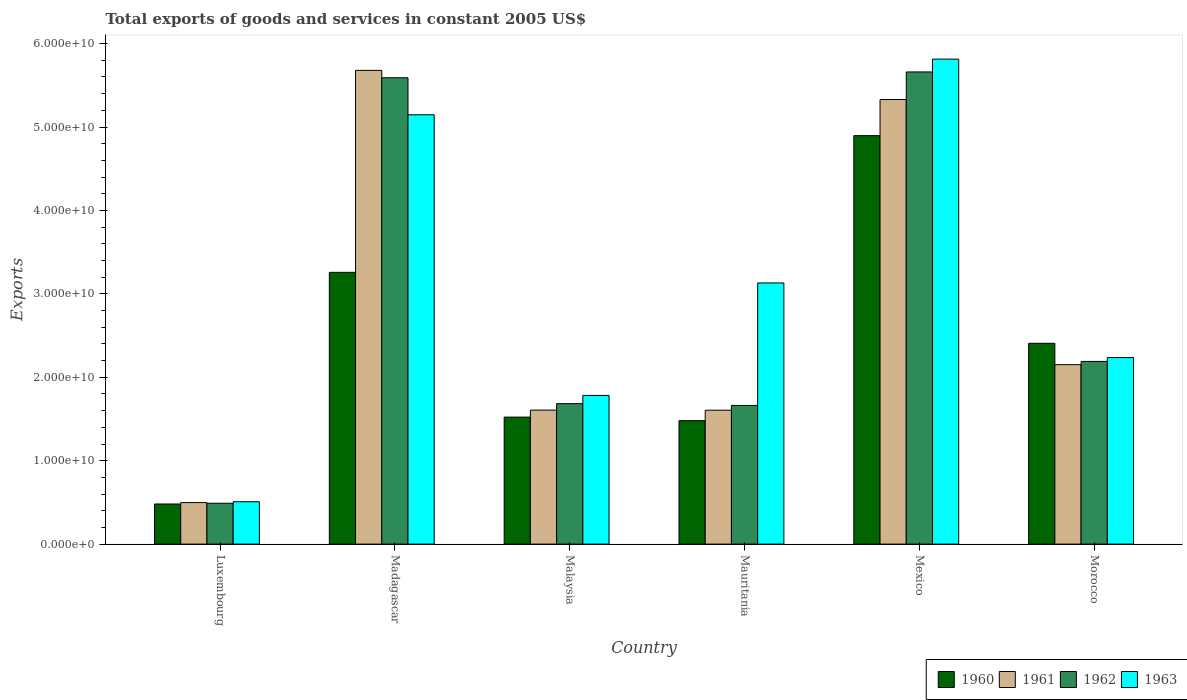How many groups of bars are there?
Give a very brief answer. 6. Are the number of bars per tick equal to the number of legend labels?
Ensure brevity in your answer.  Yes. How many bars are there on the 1st tick from the left?
Provide a short and direct response. 4. What is the label of the 2nd group of bars from the left?
Your answer should be very brief. Madagascar. What is the total exports of goods and services in 1963 in Morocco?
Your answer should be compact. 2.24e+1. Across all countries, what is the maximum total exports of goods and services in 1962?
Make the answer very short. 5.66e+1. Across all countries, what is the minimum total exports of goods and services in 1963?
Provide a succinct answer. 5.08e+09. In which country was the total exports of goods and services in 1962 maximum?
Ensure brevity in your answer.  Mexico. In which country was the total exports of goods and services in 1960 minimum?
Your response must be concise. Luxembourg. What is the total total exports of goods and services in 1962 in the graph?
Provide a succinct answer. 1.73e+11. What is the difference between the total exports of goods and services in 1963 in Luxembourg and that in Mauritania?
Offer a very short reply. -2.62e+1. What is the difference between the total exports of goods and services in 1960 in Mauritania and the total exports of goods and services in 1961 in Morocco?
Give a very brief answer. -6.71e+09. What is the average total exports of goods and services in 1961 per country?
Provide a succinct answer. 2.81e+1. What is the difference between the total exports of goods and services of/in 1961 and total exports of goods and services of/in 1963 in Malaysia?
Keep it short and to the point. -1.76e+09. In how many countries, is the total exports of goods and services in 1961 greater than 34000000000 US$?
Provide a succinct answer. 2. What is the ratio of the total exports of goods and services in 1963 in Malaysia to that in Mauritania?
Ensure brevity in your answer.  0.57. Is the total exports of goods and services in 1960 in Malaysia less than that in Mexico?
Provide a short and direct response. Yes. Is the difference between the total exports of goods and services in 1961 in Madagascar and Mexico greater than the difference between the total exports of goods and services in 1963 in Madagascar and Mexico?
Offer a terse response. Yes. What is the difference between the highest and the second highest total exports of goods and services in 1961?
Your response must be concise. 3.50e+09. What is the difference between the highest and the lowest total exports of goods and services in 1962?
Provide a succinct answer. 5.17e+1. In how many countries, is the total exports of goods and services in 1960 greater than the average total exports of goods and services in 1960 taken over all countries?
Your answer should be compact. 3. Is the sum of the total exports of goods and services in 1961 in Luxembourg and Malaysia greater than the maximum total exports of goods and services in 1963 across all countries?
Your answer should be very brief. No. Is it the case that in every country, the sum of the total exports of goods and services in 1961 and total exports of goods and services in 1963 is greater than the sum of total exports of goods and services in 1962 and total exports of goods and services in 1960?
Give a very brief answer. No. Is it the case that in every country, the sum of the total exports of goods and services in 1961 and total exports of goods and services in 1960 is greater than the total exports of goods and services in 1963?
Your answer should be very brief. No. Are all the bars in the graph horizontal?
Offer a very short reply. No. What is the difference between two consecutive major ticks on the Y-axis?
Offer a terse response. 1.00e+1. Are the values on the major ticks of Y-axis written in scientific E-notation?
Offer a terse response. Yes. Does the graph contain grids?
Your answer should be very brief. No. Where does the legend appear in the graph?
Keep it short and to the point. Bottom right. How many legend labels are there?
Make the answer very short. 4. What is the title of the graph?
Your answer should be compact. Total exports of goods and services in constant 2005 US$. What is the label or title of the X-axis?
Your answer should be compact. Country. What is the label or title of the Y-axis?
Provide a succinct answer. Exports. What is the Exports of 1960 in Luxembourg?
Make the answer very short. 4.81e+09. What is the Exports of 1961 in Luxembourg?
Offer a terse response. 4.98e+09. What is the Exports in 1962 in Luxembourg?
Make the answer very short. 4.90e+09. What is the Exports of 1963 in Luxembourg?
Your answer should be compact. 5.08e+09. What is the Exports in 1960 in Madagascar?
Offer a very short reply. 3.26e+1. What is the Exports in 1961 in Madagascar?
Provide a short and direct response. 5.68e+1. What is the Exports in 1962 in Madagascar?
Your response must be concise. 5.59e+1. What is the Exports in 1963 in Madagascar?
Your answer should be very brief. 5.15e+1. What is the Exports in 1960 in Malaysia?
Offer a terse response. 1.52e+1. What is the Exports of 1961 in Malaysia?
Ensure brevity in your answer.  1.61e+1. What is the Exports of 1962 in Malaysia?
Your response must be concise. 1.68e+1. What is the Exports in 1963 in Malaysia?
Make the answer very short. 1.78e+1. What is the Exports of 1960 in Mauritania?
Your answer should be very brief. 1.48e+1. What is the Exports in 1961 in Mauritania?
Provide a succinct answer. 1.61e+1. What is the Exports of 1962 in Mauritania?
Make the answer very short. 1.66e+1. What is the Exports of 1963 in Mauritania?
Your response must be concise. 3.13e+1. What is the Exports of 1960 in Mexico?
Make the answer very short. 4.90e+1. What is the Exports of 1961 in Mexico?
Give a very brief answer. 5.33e+1. What is the Exports of 1962 in Mexico?
Offer a very short reply. 5.66e+1. What is the Exports of 1963 in Mexico?
Keep it short and to the point. 5.81e+1. What is the Exports of 1960 in Morocco?
Your answer should be compact. 2.41e+1. What is the Exports in 1961 in Morocco?
Your answer should be very brief. 2.15e+1. What is the Exports in 1962 in Morocco?
Provide a succinct answer. 2.19e+1. What is the Exports of 1963 in Morocco?
Your response must be concise. 2.24e+1. Across all countries, what is the maximum Exports in 1960?
Make the answer very short. 4.90e+1. Across all countries, what is the maximum Exports of 1961?
Provide a succinct answer. 5.68e+1. Across all countries, what is the maximum Exports in 1962?
Your response must be concise. 5.66e+1. Across all countries, what is the maximum Exports of 1963?
Your answer should be very brief. 5.81e+1. Across all countries, what is the minimum Exports in 1960?
Provide a short and direct response. 4.81e+09. Across all countries, what is the minimum Exports of 1961?
Provide a short and direct response. 4.98e+09. Across all countries, what is the minimum Exports of 1962?
Your response must be concise. 4.90e+09. Across all countries, what is the minimum Exports in 1963?
Provide a short and direct response. 5.08e+09. What is the total Exports of 1960 in the graph?
Give a very brief answer. 1.40e+11. What is the total Exports of 1961 in the graph?
Provide a succinct answer. 1.69e+11. What is the total Exports of 1962 in the graph?
Provide a succinct answer. 1.73e+11. What is the total Exports in 1963 in the graph?
Offer a terse response. 1.86e+11. What is the difference between the Exports in 1960 in Luxembourg and that in Madagascar?
Offer a very short reply. -2.78e+1. What is the difference between the Exports in 1961 in Luxembourg and that in Madagascar?
Give a very brief answer. -5.18e+1. What is the difference between the Exports of 1962 in Luxembourg and that in Madagascar?
Your answer should be compact. -5.10e+1. What is the difference between the Exports of 1963 in Luxembourg and that in Madagascar?
Offer a very short reply. -4.64e+1. What is the difference between the Exports of 1960 in Luxembourg and that in Malaysia?
Ensure brevity in your answer.  -1.04e+1. What is the difference between the Exports in 1961 in Luxembourg and that in Malaysia?
Provide a succinct answer. -1.11e+1. What is the difference between the Exports in 1962 in Luxembourg and that in Malaysia?
Ensure brevity in your answer.  -1.19e+1. What is the difference between the Exports of 1963 in Luxembourg and that in Malaysia?
Give a very brief answer. -1.27e+1. What is the difference between the Exports in 1960 in Luxembourg and that in Mauritania?
Your answer should be compact. -9.99e+09. What is the difference between the Exports in 1961 in Luxembourg and that in Mauritania?
Your response must be concise. -1.11e+1. What is the difference between the Exports in 1962 in Luxembourg and that in Mauritania?
Offer a very short reply. -1.17e+1. What is the difference between the Exports in 1963 in Luxembourg and that in Mauritania?
Your answer should be very brief. -2.62e+1. What is the difference between the Exports of 1960 in Luxembourg and that in Mexico?
Your response must be concise. -4.42e+1. What is the difference between the Exports of 1961 in Luxembourg and that in Mexico?
Make the answer very short. -4.83e+1. What is the difference between the Exports in 1962 in Luxembourg and that in Mexico?
Offer a terse response. -5.17e+1. What is the difference between the Exports of 1963 in Luxembourg and that in Mexico?
Keep it short and to the point. -5.31e+1. What is the difference between the Exports in 1960 in Luxembourg and that in Morocco?
Your response must be concise. -1.93e+1. What is the difference between the Exports in 1961 in Luxembourg and that in Morocco?
Your answer should be compact. -1.65e+1. What is the difference between the Exports in 1962 in Luxembourg and that in Morocco?
Provide a short and direct response. -1.70e+1. What is the difference between the Exports of 1963 in Luxembourg and that in Morocco?
Your response must be concise. -1.73e+1. What is the difference between the Exports in 1960 in Madagascar and that in Malaysia?
Make the answer very short. 1.74e+1. What is the difference between the Exports of 1961 in Madagascar and that in Malaysia?
Provide a short and direct response. 4.07e+1. What is the difference between the Exports of 1962 in Madagascar and that in Malaysia?
Keep it short and to the point. 3.91e+1. What is the difference between the Exports in 1963 in Madagascar and that in Malaysia?
Ensure brevity in your answer.  3.36e+1. What is the difference between the Exports in 1960 in Madagascar and that in Mauritania?
Provide a succinct answer. 1.78e+1. What is the difference between the Exports of 1961 in Madagascar and that in Mauritania?
Provide a short and direct response. 4.07e+1. What is the difference between the Exports in 1962 in Madagascar and that in Mauritania?
Provide a succinct answer. 3.93e+1. What is the difference between the Exports in 1963 in Madagascar and that in Mauritania?
Keep it short and to the point. 2.02e+1. What is the difference between the Exports in 1960 in Madagascar and that in Mexico?
Your response must be concise. -1.64e+1. What is the difference between the Exports of 1961 in Madagascar and that in Mexico?
Ensure brevity in your answer.  3.50e+09. What is the difference between the Exports in 1962 in Madagascar and that in Mexico?
Provide a short and direct response. -6.99e+08. What is the difference between the Exports of 1963 in Madagascar and that in Mexico?
Provide a short and direct response. -6.67e+09. What is the difference between the Exports of 1960 in Madagascar and that in Morocco?
Give a very brief answer. 8.51e+09. What is the difference between the Exports in 1961 in Madagascar and that in Morocco?
Provide a succinct answer. 3.53e+1. What is the difference between the Exports in 1962 in Madagascar and that in Morocco?
Offer a very short reply. 3.40e+1. What is the difference between the Exports of 1963 in Madagascar and that in Morocco?
Give a very brief answer. 2.91e+1. What is the difference between the Exports in 1960 in Malaysia and that in Mauritania?
Offer a terse response. 4.22e+08. What is the difference between the Exports of 1961 in Malaysia and that in Mauritania?
Keep it short and to the point. 1.20e+07. What is the difference between the Exports in 1962 in Malaysia and that in Mauritania?
Offer a terse response. 2.15e+08. What is the difference between the Exports of 1963 in Malaysia and that in Mauritania?
Provide a succinct answer. -1.35e+1. What is the difference between the Exports of 1960 in Malaysia and that in Mexico?
Provide a succinct answer. -3.37e+1. What is the difference between the Exports in 1961 in Malaysia and that in Mexico?
Give a very brief answer. -3.72e+1. What is the difference between the Exports in 1962 in Malaysia and that in Mexico?
Your response must be concise. -3.98e+1. What is the difference between the Exports in 1963 in Malaysia and that in Mexico?
Offer a terse response. -4.03e+1. What is the difference between the Exports of 1960 in Malaysia and that in Morocco?
Your answer should be very brief. -8.85e+09. What is the difference between the Exports of 1961 in Malaysia and that in Morocco?
Ensure brevity in your answer.  -5.44e+09. What is the difference between the Exports in 1962 in Malaysia and that in Morocco?
Your answer should be very brief. -5.06e+09. What is the difference between the Exports of 1963 in Malaysia and that in Morocco?
Keep it short and to the point. -4.54e+09. What is the difference between the Exports in 1960 in Mauritania and that in Mexico?
Give a very brief answer. -3.42e+1. What is the difference between the Exports of 1961 in Mauritania and that in Mexico?
Make the answer very short. -3.72e+1. What is the difference between the Exports in 1962 in Mauritania and that in Mexico?
Give a very brief answer. -4.00e+1. What is the difference between the Exports of 1963 in Mauritania and that in Mexico?
Keep it short and to the point. -2.68e+1. What is the difference between the Exports of 1960 in Mauritania and that in Morocco?
Keep it short and to the point. -9.27e+09. What is the difference between the Exports of 1961 in Mauritania and that in Morocco?
Your answer should be very brief. -5.46e+09. What is the difference between the Exports of 1962 in Mauritania and that in Morocco?
Offer a terse response. -5.28e+09. What is the difference between the Exports of 1963 in Mauritania and that in Morocco?
Your response must be concise. 8.95e+09. What is the difference between the Exports of 1960 in Mexico and that in Morocco?
Provide a short and direct response. 2.49e+1. What is the difference between the Exports in 1961 in Mexico and that in Morocco?
Provide a short and direct response. 3.18e+1. What is the difference between the Exports of 1962 in Mexico and that in Morocco?
Your response must be concise. 3.47e+1. What is the difference between the Exports in 1963 in Mexico and that in Morocco?
Offer a very short reply. 3.58e+1. What is the difference between the Exports of 1960 in Luxembourg and the Exports of 1961 in Madagascar?
Keep it short and to the point. -5.20e+1. What is the difference between the Exports in 1960 in Luxembourg and the Exports in 1962 in Madagascar?
Offer a terse response. -5.11e+1. What is the difference between the Exports in 1960 in Luxembourg and the Exports in 1963 in Madagascar?
Your response must be concise. -4.67e+1. What is the difference between the Exports in 1961 in Luxembourg and the Exports in 1962 in Madagascar?
Offer a terse response. -5.09e+1. What is the difference between the Exports of 1961 in Luxembourg and the Exports of 1963 in Madagascar?
Provide a succinct answer. -4.65e+1. What is the difference between the Exports of 1962 in Luxembourg and the Exports of 1963 in Madagascar?
Make the answer very short. -4.66e+1. What is the difference between the Exports in 1960 in Luxembourg and the Exports in 1961 in Malaysia?
Keep it short and to the point. -1.13e+1. What is the difference between the Exports of 1960 in Luxembourg and the Exports of 1962 in Malaysia?
Your answer should be compact. -1.20e+1. What is the difference between the Exports of 1960 in Luxembourg and the Exports of 1963 in Malaysia?
Provide a succinct answer. -1.30e+1. What is the difference between the Exports of 1961 in Luxembourg and the Exports of 1962 in Malaysia?
Your response must be concise. -1.19e+1. What is the difference between the Exports in 1961 in Luxembourg and the Exports in 1963 in Malaysia?
Your answer should be compact. -1.28e+1. What is the difference between the Exports in 1962 in Luxembourg and the Exports in 1963 in Malaysia?
Offer a terse response. -1.29e+1. What is the difference between the Exports of 1960 in Luxembourg and the Exports of 1961 in Mauritania?
Give a very brief answer. -1.12e+1. What is the difference between the Exports in 1960 in Luxembourg and the Exports in 1962 in Mauritania?
Provide a short and direct response. -1.18e+1. What is the difference between the Exports of 1960 in Luxembourg and the Exports of 1963 in Mauritania?
Offer a very short reply. -2.65e+1. What is the difference between the Exports in 1961 in Luxembourg and the Exports in 1962 in Mauritania?
Provide a succinct answer. -1.16e+1. What is the difference between the Exports of 1961 in Luxembourg and the Exports of 1963 in Mauritania?
Keep it short and to the point. -2.63e+1. What is the difference between the Exports of 1962 in Luxembourg and the Exports of 1963 in Mauritania?
Give a very brief answer. -2.64e+1. What is the difference between the Exports in 1960 in Luxembourg and the Exports in 1961 in Mexico?
Keep it short and to the point. -4.85e+1. What is the difference between the Exports in 1960 in Luxembourg and the Exports in 1962 in Mexico?
Keep it short and to the point. -5.18e+1. What is the difference between the Exports in 1960 in Luxembourg and the Exports in 1963 in Mexico?
Make the answer very short. -5.33e+1. What is the difference between the Exports of 1961 in Luxembourg and the Exports of 1962 in Mexico?
Provide a short and direct response. -5.16e+1. What is the difference between the Exports of 1961 in Luxembourg and the Exports of 1963 in Mexico?
Provide a short and direct response. -5.32e+1. What is the difference between the Exports of 1962 in Luxembourg and the Exports of 1963 in Mexico?
Make the answer very short. -5.32e+1. What is the difference between the Exports in 1960 in Luxembourg and the Exports in 1961 in Morocco?
Ensure brevity in your answer.  -1.67e+1. What is the difference between the Exports in 1960 in Luxembourg and the Exports in 1962 in Morocco?
Provide a short and direct response. -1.71e+1. What is the difference between the Exports in 1960 in Luxembourg and the Exports in 1963 in Morocco?
Provide a short and direct response. -1.76e+1. What is the difference between the Exports of 1961 in Luxembourg and the Exports of 1962 in Morocco?
Ensure brevity in your answer.  -1.69e+1. What is the difference between the Exports in 1961 in Luxembourg and the Exports in 1963 in Morocco?
Ensure brevity in your answer.  -1.74e+1. What is the difference between the Exports of 1962 in Luxembourg and the Exports of 1963 in Morocco?
Your response must be concise. -1.75e+1. What is the difference between the Exports in 1960 in Madagascar and the Exports in 1961 in Malaysia?
Keep it short and to the point. 1.65e+1. What is the difference between the Exports of 1960 in Madagascar and the Exports of 1962 in Malaysia?
Ensure brevity in your answer.  1.57e+1. What is the difference between the Exports in 1960 in Madagascar and the Exports in 1963 in Malaysia?
Keep it short and to the point. 1.48e+1. What is the difference between the Exports in 1961 in Madagascar and the Exports in 1962 in Malaysia?
Ensure brevity in your answer.  4.00e+1. What is the difference between the Exports in 1961 in Madagascar and the Exports in 1963 in Malaysia?
Provide a short and direct response. 3.90e+1. What is the difference between the Exports in 1962 in Madagascar and the Exports in 1963 in Malaysia?
Your answer should be very brief. 3.81e+1. What is the difference between the Exports of 1960 in Madagascar and the Exports of 1961 in Mauritania?
Ensure brevity in your answer.  1.65e+1. What is the difference between the Exports of 1960 in Madagascar and the Exports of 1962 in Mauritania?
Provide a succinct answer. 1.60e+1. What is the difference between the Exports of 1960 in Madagascar and the Exports of 1963 in Mauritania?
Your answer should be very brief. 1.27e+09. What is the difference between the Exports of 1961 in Madagascar and the Exports of 1962 in Mauritania?
Keep it short and to the point. 4.02e+1. What is the difference between the Exports of 1961 in Madagascar and the Exports of 1963 in Mauritania?
Ensure brevity in your answer.  2.55e+1. What is the difference between the Exports in 1962 in Madagascar and the Exports in 1963 in Mauritania?
Your answer should be very brief. 2.46e+1. What is the difference between the Exports in 1960 in Madagascar and the Exports in 1961 in Mexico?
Give a very brief answer. -2.07e+1. What is the difference between the Exports of 1960 in Madagascar and the Exports of 1962 in Mexico?
Give a very brief answer. -2.40e+1. What is the difference between the Exports of 1960 in Madagascar and the Exports of 1963 in Mexico?
Offer a very short reply. -2.56e+1. What is the difference between the Exports in 1961 in Madagascar and the Exports in 1962 in Mexico?
Offer a terse response. 1.89e+08. What is the difference between the Exports of 1961 in Madagascar and the Exports of 1963 in Mexico?
Your response must be concise. -1.35e+09. What is the difference between the Exports of 1962 in Madagascar and the Exports of 1963 in Mexico?
Ensure brevity in your answer.  -2.24e+09. What is the difference between the Exports in 1960 in Madagascar and the Exports in 1961 in Morocco?
Offer a very short reply. 1.11e+1. What is the difference between the Exports of 1960 in Madagascar and the Exports of 1962 in Morocco?
Offer a very short reply. 1.07e+1. What is the difference between the Exports in 1960 in Madagascar and the Exports in 1963 in Morocco?
Ensure brevity in your answer.  1.02e+1. What is the difference between the Exports in 1961 in Madagascar and the Exports in 1962 in Morocco?
Offer a terse response. 3.49e+1. What is the difference between the Exports of 1961 in Madagascar and the Exports of 1963 in Morocco?
Ensure brevity in your answer.  3.44e+1. What is the difference between the Exports in 1962 in Madagascar and the Exports in 1963 in Morocco?
Ensure brevity in your answer.  3.35e+1. What is the difference between the Exports of 1960 in Malaysia and the Exports of 1961 in Mauritania?
Provide a short and direct response. -8.31e+08. What is the difference between the Exports in 1960 in Malaysia and the Exports in 1962 in Mauritania?
Offer a terse response. -1.40e+09. What is the difference between the Exports of 1960 in Malaysia and the Exports of 1963 in Mauritania?
Make the answer very short. -1.61e+1. What is the difference between the Exports of 1961 in Malaysia and the Exports of 1962 in Mauritania?
Offer a terse response. -5.57e+08. What is the difference between the Exports of 1961 in Malaysia and the Exports of 1963 in Mauritania?
Offer a terse response. -1.52e+1. What is the difference between the Exports of 1962 in Malaysia and the Exports of 1963 in Mauritania?
Ensure brevity in your answer.  -1.45e+1. What is the difference between the Exports in 1960 in Malaysia and the Exports in 1961 in Mexico?
Your answer should be very brief. -3.81e+1. What is the difference between the Exports in 1960 in Malaysia and the Exports in 1962 in Mexico?
Provide a short and direct response. -4.14e+1. What is the difference between the Exports of 1960 in Malaysia and the Exports of 1963 in Mexico?
Keep it short and to the point. -4.29e+1. What is the difference between the Exports in 1961 in Malaysia and the Exports in 1962 in Mexico?
Your answer should be compact. -4.05e+1. What is the difference between the Exports in 1961 in Malaysia and the Exports in 1963 in Mexico?
Your answer should be very brief. -4.21e+1. What is the difference between the Exports of 1962 in Malaysia and the Exports of 1963 in Mexico?
Make the answer very short. -4.13e+1. What is the difference between the Exports of 1960 in Malaysia and the Exports of 1961 in Morocco?
Provide a succinct answer. -6.29e+09. What is the difference between the Exports of 1960 in Malaysia and the Exports of 1962 in Morocco?
Give a very brief answer. -6.68e+09. What is the difference between the Exports in 1960 in Malaysia and the Exports in 1963 in Morocco?
Provide a succinct answer. -7.14e+09. What is the difference between the Exports in 1961 in Malaysia and the Exports in 1962 in Morocco?
Your response must be concise. -5.83e+09. What is the difference between the Exports of 1961 in Malaysia and the Exports of 1963 in Morocco?
Give a very brief answer. -6.30e+09. What is the difference between the Exports of 1962 in Malaysia and the Exports of 1963 in Morocco?
Ensure brevity in your answer.  -5.53e+09. What is the difference between the Exports of 1960 in Mauritania and the Exports of 1961 in Mexico?
Offer a very short reply. -3.85e+1. What is the difference between the Exports in 1960 in Mauritania and the Exports in 1962 in Mexico?
Your answer should be compact. -4.18e+1. What is the difference between the Exports in 1960 in Mauritania and the Exports in 1963 in Mexico?
Offer a terse response. -4.33e+1. What is the difference between the Exports of 1961 in Mauritania and the Exports of 1962 in Mexico?
Make the answer very short. -4.05e+1. What is the difference between the Exports in 1961 in Mauritania and the Exports in 1963 in Mexico?
Keep it short and to the point. -4.21e+1. What is the difference between the Exports of 1962 in Mauritania and the Exports of 1963 in Mexico?
Provide a short and direct response. -4.15e+1. What is the difference between the Exports in 1960 in Mauritania and the Exports in 1961 in Morocco?
Give a very brief answer. -6.71e+09. What is the difference between the Exports in 1960 in Mauritania and the Exports in 1962 in Morocco?
Provide a succinct answer. -7.10e+09. What is the difference between the Exports of 1960 in Mauritania and the Exports of 1963 in Morocco?
Ensure brevity in your answer.  -7.56e+09. What is the difference between the Exports in 1961 in Mauritania and the Exports in 1962 in Morocco?
Give a very brief answer. -5.85e+09. What is the difference between the Exports of 1961 in Mauritania and the Exports of 1963 in Morocco?
Offer a very short reply. -6.31e+09. What is the difference between the Exports in 1962 in Mauritania and the Exports in 1963 in Morocco?
Make the answer very short. -5.74e+09. What is the difference between the Exports in 1960 in Mexico and the Exports in 1961 in Morocco?
Your answer should be compact. 2.75e+1. What is the difference between the Exports in 1960 in Mexico and the Exports in 1962 in Morocco?
Provide a short and direct response. 2.71e+1. What is the difference between the Exports in 1960 in Mexico and the Exports in 1963 in Morocco?
Your response must be concise. 2.66e+1. What is the difference between the Exports in 1961 in Mexico and the Exports in 1962 in Morocco?
Offer a terse response. 3.14e+1. What is the difference between the Exports of 1961 in Mexico and the Exports of 1963 in Morocco?
Offer a terse response. 3.09e+1. What is the difference between the Exports of 1962 in Mexico and the Exports of 1963 in Morocco?
Ensure brevity in your answer.  3.42e+1. What is the average Exports in 1960 per country?
Offer a terse response. 2.34e+1. What is the average Exports of 1961 per country?
Provide a short and direct response. 2.81e+1. What is the average Exports of 1962 per country?
Keep it short and to the point. 2.88e+1. What is the average Exports of 1963 per country?
Make the answer very short. 3.10e+1. What is the difference between the Exports of 1960 and Exports of 1961 in Luxembourg?
Keep it short and to the point. -1.68e+08. What is the difference between the Exports in 1960 and Exports in 1962 in Luxembourg?
Your response must be concise. -8.82e+07. What is the difference between the Exports of 1960 and Exports of 1963 in Luxembourg?
Your response must be concise. -2.73e+08. What is the difference between the Exports of 1961 and Exports of 1962 in Luxembourg?
Your response must be concise. 7.94e+07. What is the difference between the Exports in 1961 and Exports in 1963 in Luxembourg?
Your answer should be compact. -1.05e+08. What is the difference between the Exports of 1962 and Exports of 1963 in Luxembourg?
Give a very brief answer. -1.85e+08. What is the difference between the Exports of 1960 and Exports of 1961 in Madagascar?
Ensure brevity in your answer.  -2.42e+1. What is the difference between the Exports of 1960 and Exports of 1962 in Madagascar?
Keep it short and to the point. -2.33e+1. What is the difference between the Exports in 1960 and Exports in 1963 in Madagascar?
Provide a succinct answer. -1.89e+1. What is the difference between the Exports in 1961 and Exports in 1962 in Madagascar?
Provide a succinct answer. 8.87e+08. What is the difference between the Exports in 1961 and Exports in 1963 in Madagascar?
Ensure brevity in your answer.  5.32e+09. What is the difference between the Exports in 1962 and Exports in 1963 in Madagascar?
Provide a succinct answer. 4.44e+09. What is the difference between the Exports in 1960 and Exports in 1961 in Malaysia?
Make the answer very short. -8.42e+08. What is the difference between the Exports of 1960 and Exports of 1962 in Malaysia?
Keep it short and to the point. -1.61e+09. What is the difference between the Exports in 1960 and Exports in 1963 in Malaysia?
Ensure brevity in your answer.  -2.60e+09. What is the difference between the Exports in 1961 and Exports in 1962 in Malaysia?
Ensure brevity in your answer.  -7.72e+08. What is the difference between the Exports of 1961 and Exports of 1963 in Malaysia?
Your answer should be compact. -1.76e+09. What is the difference between the Exports in 1962 and Exports in 1963 in Malaysia?
Provide a succinct answer. -9.85e+08. What is the difference between the Exports of 1960 and Exports of 1961 in Mauritania?
Provide a short and direct response. -1.25e+09. What is the difference between the Exports of 1960 and Exports of 1962 in Mauritania?
Offer a terse response. -1.82e+09. What is the difference between the Exports of 1960 and Exports of 1963 in Mauritania?
Offer a terse response. -1.65e+1. What is the difference between the Exports in 1961 and Exports in 1962 in Mauritania?
Offer a very short reply. -5.69e+08. What is the difference between the Exports of 1961 and Exports of 1963 in Mauritania?
Make the answer very short. -1.53e+1. What is the difference between the Exports in 1962 and Exports in 1963 in Mauritania?
Provide a succinct answer. -1.47e+1. What is the difference between the Exports of 1960 and Exports of 1961 in Mexico?
Offer a terse response. -4.33e+09. What is the difference between the Exports in 1960 and Exports in 1962 in Mexico?
Make the answer very short. -7.64e+09. What is the difference between the Exports in 1960 and Exports in 1963 in Mexico?
Make the answer very short. -9.17e+09. What is the difference between the Exports of 1961 and Exports of 1962 in Mexico?
Offer a terse response. -3.31e+09. What is the difference between the Exports of 1961 and Exports of 1963 in Mexico?
Give a very brief answer. -4.84e+09. What is the difference between the Exports of 1962 and Exports of 1963 in Mexico?
Provide a succinct answer. -1.54e+09. What is the difference between the Exports of 1960 and Exports of 1961 in Morocco?
Keep it short and to the point. 2.56e+09. What is the difference between the Exports in 1960 and Exports in 1962 in Morocco?
Your answer should be compact. 2.17e+09. What is the difference between the Exports of 1960 and Exports of 1963 in Morocco?
Give a very brief answer. 1.71e+09. What is the difference between the Exports in 1961 and Exports in 1962 in Morocco?
Your response must be concise. -3.89e+08. What is the difference between the Exports in 1961 and Exports in 1963 in Morocco?
Your answer should be compact. -8.54e+08. What is the difference between the Exports in 1962 and Exports in 1963 in Morocco?
Give a very brief answer. -4.65e+08. What is the ratio of the Exports in 1960 in Luxembourg to that in Madagascar?
Your answer should be compact. 0.15. What is the ratio of the Exports in 1961 in Luxembourg to that in Madagascar?
Ensure brevity in your answer.  0.09. What is the ratio of the Exports in 1962 in Luxembourg to that in Madagascar?
Give a very brief answer. 0.09. What is the ratio of the Exports of 1963 in Luxembourg to that in Madagascar?
Give a very brief answer. 0.1. What is the ratio of the Exports of 1960 in Luxembourg to that in Malaysia?
Make the answer very short. 0.32. What is the ratio of the Exports in 1961 in Luxembourg to that in Malaysia?
Your answer should be compact. 0.31. What is the ratio of the Exports of 1962 in Luxembourg to that in Malaysia?
Your response must be concise. 0.29. What is the ratio of the Exports of 1963 in Luxembourg to that in Malaysia?
Ensure brevity in your answer.  0.29. What is the ratio of the Exports in 1960 in Luxembourg to that in Mauritania?
Your answer should be compact. 0.32. What is the ratio of the Exports in 1961 in Luxembourg to that in Mauritania?
Your answer should be very brief. 0.31. What is the ratio of the Exports of 1962 in Luxembourg to that in Mauritania?
Offer a very short reply. 0.29. What is the ratio of the Exports of 1963 in Luxembourg to that in Mauritania?
Your answer should be very brief. 0.16. What is the ratio of the Exports of 1960 in Luxembourg to that in Mexico?
Keep it short and to the point. 0.1. What is the ratio of the Exports in 1961 in Luxembourg to that in Mexico?
Offer a very short reply. 0.09. What is the ratio of the Exports of 1962 in Luxembourg to that in Mexico?
Your answer should be very brief. 0.09. What is the ratio of the Exports in 1963 in Luxembourg to that in Mexico?
Offer a very short reply. 0.09. What is the ratio of the Exports in 1960 in Luxembourg to that in Morocco?
Make the answer very short. 0.2. What is the ratio of the Exports of 1961 in Luxembourg to that in Morocco?
Offer a terse response. 0.23. What is the ratio of the Exports in 1962 in Luxembourg to that in Morocco?
Offer a terse response. 0.22. What is the ratio of the Exports in 1963 in Luxembourg to that in Morocco?
Provide a short and direct response. 0.23. What is the ratio of the Exports in 1960 in Madagascar to that in Malaysia?
Your answer should be very brief. 2.14. What is the ratio of the Exports of 1961 in Madagascar to that in Malaysia?
Ensure brevity in your answer.  3.54. What is the ratio of the Exports of 1962 in Madagascar to that in Malaysia?
Offer a terse response. 3.32. What is the ratio of the Exports of 1963 in Madagascar to that in Malaysia?
Offer a very short reply. 2.89. What is the ratio of the Exports in 1960 in Madagascar to that in Mauritania?
Keep it short and to the point. 2.2. What is the ratio of the Exports of 1961 in Madagascar to that in Mauritania?
Offer a very short reply. 3.54. What is the ratio of the Exports of 1962 in Madagascar to that in Mauritania?
Provide a short and direct response. 3.36. What is the ratio of the Exports in 1963 in Madagascar to that in Mauritania?
Ensure brevity in your answer.  1.64. What is the ratio of the Exports in 1960 in Madagascar to that in Mexico?
Keep it short and to the point. 0.67. What is the ratio of the Exports of 1961 in Madagascar to that in Mexico?
Offer a terse response. 1.07. What is the ratio of the Exports in 1962 in Madagascar to that in Mexico?
Your answer should be very brief. 0.99. What is the ratio of the Exports of 1963 in Madagascar to that in Mexico?
Make the answer very short. 0.89. What is the ratio of the Exports in 1960 in Madagascar to that in Morocco?
Provide a short and direct response. 1.35. What is the ratio of the Exports in 1961 in Madagascar to that in Morocco?
Offer a terse response. 2.64. What is the ratio of the Exports in 1962 in Madagascar to that in Morocco?
Make the answer very short. 2.55. What is the ratio of the Exports of 1963 in Madagascar to that in Morocco?
Keep it short and to the point. 2.3. What is the ratio of the Exports of 1960 in Malaysia to that in Mauritania?
Your answer should be compact. 1.03. What is the ratio of the Exports of 1962 in Malaysia to that in Mauritania?
Offer a very short reply. 1.01. What is the ratio of the Exports in 1963 in Malaysia to that in Mauritania?
Your answer should be very brief. 0.57. What is the ratio of the Exports of 1960 in Malaysia to that in Mexico?
Provide a short and direct response. 0.31. What is the ratio of the Exports of 1961 in Malaysia to that in Mexico?
Offer a terse response. 0.3. What is the ratio of the Exports in 1962 in Malaysia to that in Mexico?
Provide a short and direct response. 0.3. What is the ratio of the Exports in 1963 in Malaysia to that in Mexico?
Your answer should be very brief. 0.31. What is the ratio of the Exports of 1960 in Malaysia to that in Morocco?
Give a very brief answer. 0.63. What is the ratio of the Exports in 1961 in Malaysia to that in Morocco?
Your response must be concise. 0.75. What is the ratio of the Exports in 1962 in Malaysia to that in Morocco?
Make the answer very short. 0.77. What is the ratio of the Exports in 1963 in Malaysia to that in Morocco?
Keep it short and to the point. 0.8. What is the ratio of the Exports of 1960 in Mauritania to that in Mexico?
Offer a very short reply. 0.3. What is the ratio of the Exports in 1961 in Mauritania to that in Mexico?
Give a very brief answer. 0.3. What is the ratio of the Exports of 1962 in Mauritania to that in Mexico?
Provide a succinct answer. 0.29. What is the ratio of the Exports of 1963 in Mauritania to that in Mexico?
Offer a terse response. 0.54. What is the ratio of the Exports of 1960 in Mauritania to that in Morocco?
Your answer should be compact. 0.61. What is the ratio of the Exports in 1961 in Mauritania to that in Morocco?
Make the answer very short. 0.75. What is the ratio of the Exports of 1962 in Mauritania to that in Morocco?
Your response must be concise. 0.76. What is the ratio of the Exports of 1963 in Mauritania to that in Morocco?
Provide a short and direct response. 1.4. What is the ratio of the Exports in 1960 in Mexico to that in Morocco?
Your response must be concise. 2.03. What is the ratio of the Exports in 1961 in Mexico to that in Morocco?
Give a very brief answer. 2.48. What is the ratio of the Exports in 1962 in Mexico to that in Morocco?
Offer a very short reply. 2.58. What is the ratio of the Exports in 1963 in Mexico to that in Morocco?
Offer a terse response. 2.6. What is the difference between the highest and the second highest Exports in 1960?
Offer a very short reply. 1.64e+1. What is the difference between the highest and the second highest Exports in 1961?
Your response must be concise. 3.50e+09. What is the difference between the highest and the second highest Exports of 1962?
Your answer should be compact. 6.99e+08. What is the difference between the highest and the second highest Exports in 1963?
Provide a short and direct response. 6.67e+09. What is the difference between the highest and the lowest Exports in 1960?
Offer a terse response. 4.42e+1. What is the difference between the highest and the lowest Exports in 1961?
Offer a terse response. 5.18e+1. What is the difference between the highest and the lowest Exports in 1962?
Your response must be concise. 5.17e+1. What is the difference between the highest and the lowest Exports of 1963?
Give a very brief answer. 5.31e+1. 